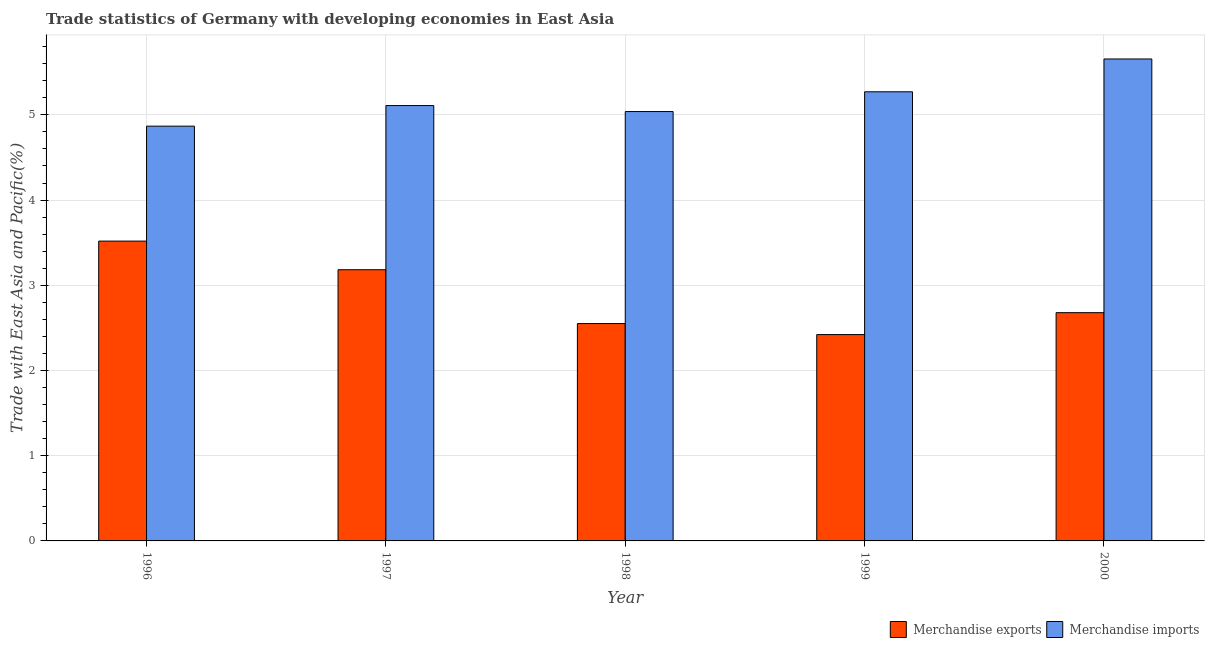Are the number of bars per tick equal to the number of legend labels?
Provide a succinct answer. Yes. How many bars are there on the 3rd tick from the left?
Provide a short and direct response. 2. What is the label of the 5th group of bars from the left?
Offer a terse response. 2000. What is the merchandise imports in 2000?
Offer a very short reply. 5.66. Across all years, what is the maximum merchandise exports?
Offer a very short reply. 3.52. Across all years, what is the minimum merchandise exports?
Your response must be concise. 2.42. In which year was the merchandise exports maximum?
Ensure brevity in your answer.  1996. What is the total merchandise imports in the graph?
Your response must be concise. 25.94. What is the difference between the merchandise exports in 1996 and that in 1998?
Ensure brevity in your answer.  0.97. What is the difference between the merchandise exports in 2000 and the merchandise imports in 1998?
Make the answer very short. 0.13. What is the average merchandise imports per year?
Provide a succinct answer. 5.19. What is the ratio of the merchandise exports in 1998 to that in 1999?
Keep it short and to the point. 1.05. Is the merchandise imports in 1998 less than that in 2000?
Your answer should be very brief. Yes. Is the difference between the merchandise imports in 1999 and 2000 greater than the difference between the merchandise exports in 1999 and 2000?
Your answer should be compact. No. What is the difference between the highest and the second highest merchandise exports?
Your answer should be compact. 0.34. What is the difference between the highest and the lowest merchandise imports?
Provide a short and direct response. 0.79. What does the 2nd bar from the left in 1997 represents?
Your answer should be compact. Merchandise imports. How many bars are there?
Ensure brevity in your answer.  10. What is the difference between two consecutive major ticks on the Y-axis?
Give a very brief answer. 1. Does the graph contain any zero values?
Give a very brief answer. No. Where does the legend appear in the graph?
Your answer should be very brief. Bottom right. How many legend labels are there?
Keep it short and to the point. 2. What is the title of the graph?
Keep it short and to the point. Trade statistics of Germany with developing economies in East Asia. What is the label or title of the Y-axis?
Ensure brevity in your answer.  Trade with East Asia and Pacific(%). What is the Trade with East Asia and Pacific(%) in Merchandise exports in 1996?
Your answer should be compact. 3.52. What is the Trade with East Asia and Pacific(%) of Merchandise imports in 1996?
Offer a terse response. 4.87. What is the Trade with East Asia and Pacific(%) of Merchandise exports in 1997?
Offer a terse response. 3.18. What is the Trade with East Asia and Pacific(%) of Merchandise imports in 1997?
Keep it short and to the point. 5.11. What is the Trade with East Asia and Pacific(%) in Merchandise exports in 1998?
Provide a short and direct response. 2.55. What is the Trade with East Asia and Pacific(%) of Merchandise imports in 1998?
Give a very brief answer. 5.04. What is the Trade with East Asia and Pacific(%) of Merchandise exports in 1999?
Your answer should be compact. 2.42. What is the Trade with East Asia and Pacific(%) in Merchandise imports in 1999?
Your response must be concise. 5.27. What is the Trade with East Asia and Pacific(%) in Merchandise exports in 2000?
Make the answer very short. 2.68. What is the Trade with East Asia and Pacific(%) of Merchandise imports in 2000?
Make the answer very short. 5.66. Across all years, what is the maximum Trade with East Asia and Pacific(%) in Merchandise exports?
Keep it short and to the point. 3.52. Across all years, what is the maximum Trade with East Asia and Pacific(%) in Merchandise imports?
Give a very brief answer. 5.66. Across all years, what is the minimum Trade with East Asia and Pacific(%) of Merchandise exports?
Make the answer very short. 2.42. Across all years, what is the minimum Trade with East Asia and Pacific(%) in Merchandise imports?
Ensure brevity in your answer.  4.87. What is the total Trade with East Asia and Pacific(%) in Merchandise exports in the graph?
Your response must be concise. 14.35. What is the total Trade with East Asia and Pacific(%) of Merchandise imports in the graph?
Keep it short and to the point. 25.94. What is the difference between the Trade with East Asia and Pacific(%) of Merchandise exports in 1996 and that in 1997?
Provide a succinct answer. 0.34. What is the difference between the Trade with East Asia and Pacific(%) in Merchandise imports in 1996 and that in 1997?
Your response must be concise. -0.24. What is the difference between the Trade with East Asia and Pacific(%) of Merchandise exports in 1996 and that in 1998?
Offer a terse response. 0.97. What is the difference between the Trade with East Asia and Pacific(%) in Merchandise imports in 1996 and that in 1998?
Give a very brief answer. -0.17. What is the difference between the Trade with East Asia and Pacific(%) of Merchandise exports in 1996 and that in 1999?
Offer a very short reply. 1.1. What is the difference between the Trade with East Asia and Pacific(%) in Merchandise imports in 1996 and that in 1999?
Your response must be concise. -0.4. What is the difference between the Trade with East Asia and Pacific(%) of Merchandise exports in 1996 and that in 2000?
Ensure brevity in your answer.  0.84. What is the difference between the Trade with East Asia and Pacific(%) in Merchandise imports in 1996 and that in 2000?
Keep it short and to the point. -0.79. What is the difference between the Trade with East Asia and Pacific(%) of Merchandise exports in 1997 and that in 1998?
Your answer should be compact. 0.63. What is the difference between the Trade with East Asia and Pacific(%) of Merchandise imports in 1997 and that in 1998?
Your response must be concise. 0.07. What is the difference between the Trade with East Asia and Pacific(%) in Merchandise exports in 1997 and that in 1999?
Provide a short and direct response. 0.76. What is the difference between the Trade with East Asia and Pacific(%) in Merchandise imports in 1997 and that in 1999?
Provide a short and direct response. -0.16. What is the difference between the Trade with East Asia and Pacific(%) in Merchandise exports in 1997 and that in 2000?
Your answer should be compact. 0.5. What is the difference between the Trade with East Asia and Pacific(%) of Merchandise imports in 1997 and that in 2000?
Offer a very short reply. -0.55. What is the difference between the Trade with East Asia and Pacific(%) in Merchandise exports in 1998 and that in 1999?
Offer a very short reply. 0.13. What is the difference between the Trade with East Asia and Pacific(%) of Merchandise imports in 1998 and that in 1999?
Offer a very short reply. -0.23. What is the difference between the Trade with East Asia and Pacific(%) of Merchandise exports in 1998 and that in 2000?
Your answer should be compact. -0.13. What is the difference between the Trade with East Asia and Pacific(%) in Merchandise imports in 1998 and that in 2000?
Offer a terse response. -0.62. What is the difference between the Trade with East Asia and Pacific(%) in Merchandise exports in 1999 and that in 2000?
Provide a short and direct response. -0.26. What is the difference between the Trade with East Asia and Pacific(%) in Merchandise imports in 1999 and that in 2000?
Provide a short and direct response. -0.39. What is the difference between the Trade with East Asia and Pacific(%) of Merchandise exports in 1996 and the Trade with East Asia and Pacific(%) of Merchandise imports in 1997?
Provide a succinct answer. -1.59. What is the difference between the Trade with East Asia and Pacific(%) in Merchandise exports in 1996 and the Trade with East Asia and Pacific(%) in Merchandise imports in 1998?
Provide a succinct answer. -1.52. What is the difference between the Trade with East Asia and Pacific(%) of Merchandise exports in 1996 and the Trade with East Asia and Pacific(%) of Merchandise imports in 1999?
Your answer should be very brief. -1.75. What is the difference between the Trade with East Asia and Pacific(%) of Merchandise exports in 1996 and the Trade with East Asia and Pacific(%) of Merchandise imports in 2000?
Offer a terse response. -2.14. What is the difference between the Trade with East Asia and Pacific(%) in Merchandise exports in 1997 and the Trade with East Asia and Pacific(%) in Merchandise imports in 1998?
Your response must be concise. -1.86. What is the difference between the Trade with East Asia and Pacific(%) of Merchandise exports in 1997 and the Trade with East Asia and Pacific(%) of Merchandise imports in 1999?
Keep it short and to the point. -2.09. What is the difference between the Trade with East Asia and Pacific(%) of Merchandise exports in 1997 and the Trade with East Asia and Pacific(%) of Merchandise imports in 2000?
Provide a short and direct response. -2.47. What is the difference between the Trade with East Asia and Pacific(%) of Merchandise exports in 1998 and the Trade with East Asia and Pacific(%) of Merchandise imports in 1999?
Offer a terse response. -2.72. What is the difference between the Trade with East Asia and Pacific(%) in Merchandise exports in 1998 and the Trade with East Asia and Pacific(%) in Merchandise imports in 2000?
Provide a short and direct response. -3.11. What is the difference between the Trade with East Asia and Pacific(%) in Merchandise exports in 1999 and the Trade with East Asia and Pacific(%) in Merchandise imports in 2000?
Provide a succinct answer. -3.23. What is the average Trade with East Asia and Pacific(%) of Merchandise exports per year?
Offer a very short reply. 2.87. What is the average Trade with East Asia and Pacific(%) of Merchandise imports per year?
Your response must be concise. 5.19. In the year 1996, what is the difference between the Trade with East Asia and Pacific(%) in Merchandise exports and Trade with East Asia and Pacific(%) in Merchandise imports?
Ensure brevity in your answer.  -1.35. In the year 1997, what is the difference between the Trade with East Asia and Pacific(%) of Merchandise exports and Trade with East Asia and Pacific(%) of Merchandise imports?
Offer a terse response. -1.93. In the year 1998, what is the difference between the Trade with East Asia and Pacific(%) of Merchandise exports and Trade with East Asia and Pacific(%) of Merchandise imports?
Give a very brief answer. -2.49. In the year 1999, what is the difference between the Trade with East Asia and Pacific(%) of Merchandise exports and Trade with East Asia and Pacific(%) of Merchandise imports?
Ensure brevity in your answer.  -2.85. In the year 2000, what is the difference between the Trade with East Asia and Pacific(%) in Merchandise exports and Trade with East Asia and Pacific(%) in Merchandise imports?
Ensure brevity in your answer.  -2.98. What is the ratio of the Trade with East Asia and Pacific(%) of Merchandise exports in 1996 to that in 1997?
Give a very brief answer. 1.11. What is the ratio of the Trade with East Asia and Pacific(%) of Merchandise imports in 1996 to that in 1997?
Offer a terse response. 0.95. What is the ratio of the Trade with East Asia and Pacific(%) in Merchandise exports in 1996 to that in 1998?
Provide a short and direct response. 1.38. What is the ratio of the Trade with East Asia and Pacific(%) of Merchandise imports in 1996 to that in 1998?
Your answer should be compact. 0.97. What is the ratio of the Trade with East Asia and Pacific(%) of Merchandise exports in 1996 to that in 1999?
Your answer should be compact. 1.45. What is the ratio of the Trade with East Asia and Pacific(%) in Merchandise imports in 1996 to that in 1999?
Give a very brief answer. 0.92. What is the ratio of the Trade with East Asia and Pacific(%) of Merchandise exports in 1996 to that in 2000?
Offer a terse response. 1.31. What is the ratio of the Trade with East Asia and Pacific(%) of Merchandise imports in 1996 to that in 2000?
Your response must be concise. 0.86. What is the ratio of the Trade with East Asia and Pacific(%) in Merchandise exports in 1997 to that in 1998?
Provide a short and direct response. 1.25. What is the ratio of the Trade with East Asia and Pacific(%) in Merchandise imports in 1997 to that in 1998?
Keep it short and to the point. 1.01. What is the ratio of the Trade with East Asia and Pacific(%) of Merchandise exports in 1997 to that in 1999?
Provide a succinct answer. 1.31. What is the ratio of the Trade with East Asia and Pacific(%) in Merchandise imports in 1997 to that in 1999?
Make the answer very short. 0.97. What is the ratio of the Trade with East Asia and Pacific(%) in Merchandise exports in 1997 to that in 2000?
Your answer should be compact. 1.19. What is the ratio of the Trade with East Asia and Pacific(%) of Merchandise imports in 1997 to that in 2000?
Your answer should be compact. 0.9. What is the ratio of the Trade with East Asia and Pacific(%) of Merchandise exports in 1998 to that in 1999?
Make the answer very short. 1.05. What is the ratio of the Trade with East Asia and Pacific(%) in Merchandise imports in 1998 to that in 1999?
Provide a short and direct response. 0.96. What is the ratio of the Trade with East Asia and Pacific(%) in Merchandise exports in 1998 to that in 2000?
Your answer should be compact. 0.95. What is the ratio of the Trade with East Asia and Pacific(%) in Merchandise imports in 1998 to that in 2000?
Ensure brevity in your answer.  0.89. What is the ratio of the Trade with East Asia and Pacific(%) of Merchandise exports in 1999 to that in 2000?
Your answer should be compact. 0.9. What is the ratio of the Trade with East Asia and Pacific(%) in Merchandise imports in 1999 to that in 2000?
Your answer should be compact. 0.93. What is the difference between the highest and the second highest Trade with East Asia and Pacific(%) in Merchandise exports?
Ensure brevity in your answer.  0.34. What is the difference between the highest and the second highest Trade with East Asia and Pacific(%) in Merchandise imports?
Your answer should be very brief. 0.39. What is the difference between the highest and the lowest Trade with East Asia and Pacific(%) of Merchandise exports?
Your answer should be very brief. 1.1. What is the difference between the highest and the lowest Trade with East Asia and Pacific(%) of Merchandise imports?
Ensure brevity in your answer.  0.79. 